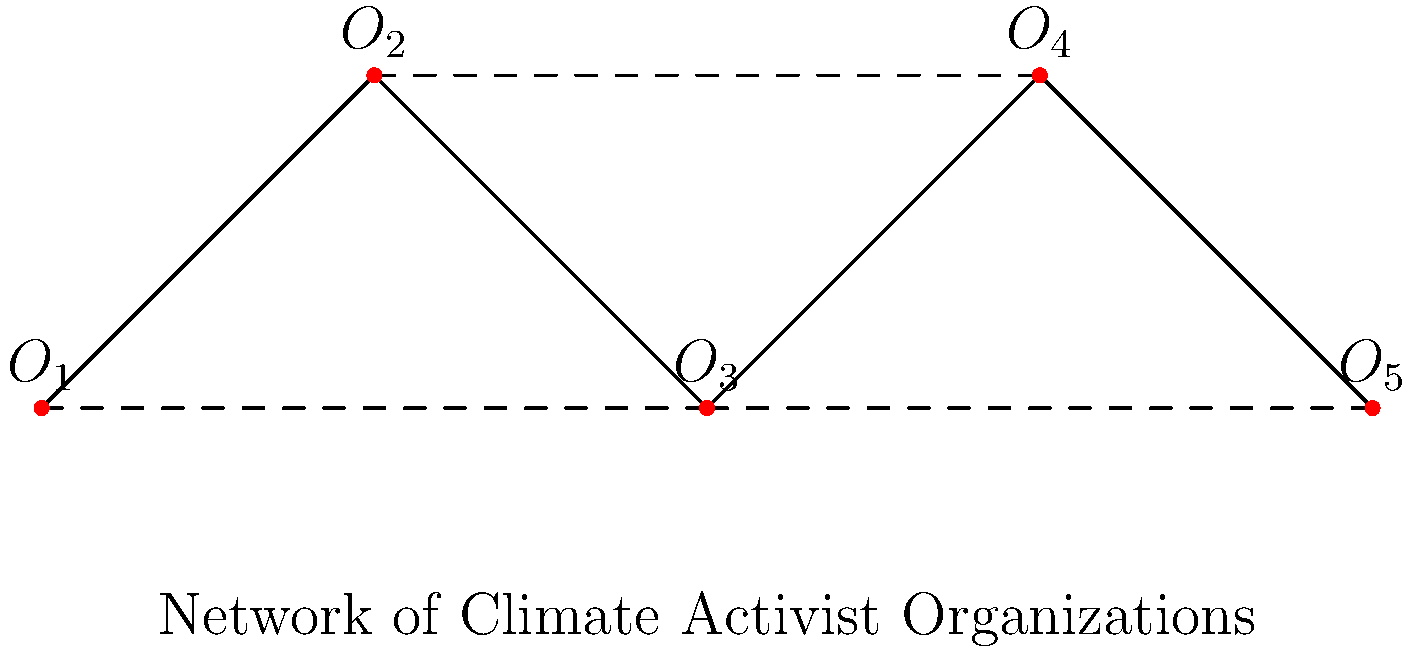In the network of climate activist organizations shown above, what is the diameter of the graph if we consider only the solid edges? To find the diameter of the graph considering only the solid edges, we need to follow these steps:

1. Identify the longest path between any two vertices using only solid edges.
2. Count the number of edges in this longest path.

Let's examine the possible paths:

- $O_1$ to $O_2$: 1 edge
- $O_1$ to $O_3$: 2 edges
- $O_1$ to $O_4$: 3 edges
- $O_1$ to $O_5$: 4 edges
- $O_2$ to $O_3$: 1 edge
- $O_2$ to $O_4$: 2 edges
- $O_2$ to $O_5$: 3 edges
- $O_3$ to $O_4$: 1 edge
- $O_3$ to $O_5$: 2 edges
- $O_4$ to $O_5$: 1 edge

The longest path is from $O_1$ to $O_5$, which consists of 4 edges.

Therefore, the diameter of the graph, considering only solid edges, is 4.
Answer: 4 